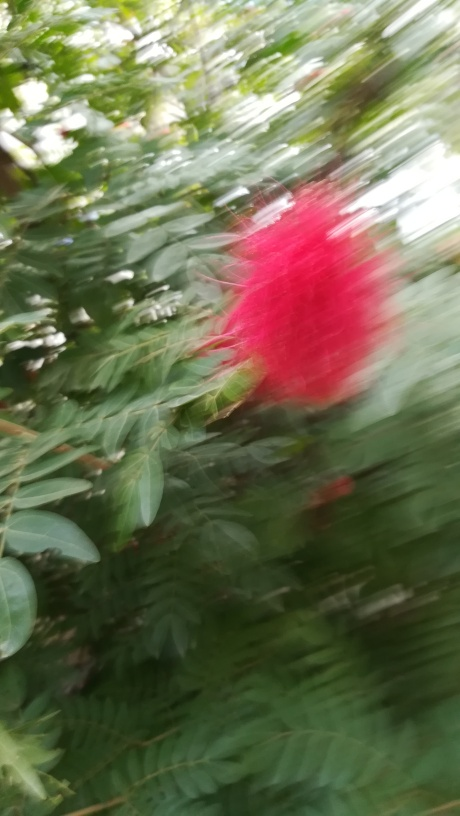How could one improve a photo of this subject under similar conditions? To improve a photo under such conditions, one could use a faster shutter speed to reduce motion blur, ensure proper focus, possibly by using manual focus settings, and use a tripod or stabilize the camera to keep it steady. Additionally, waiting for a moment when the wind has calmed could help in capturing a sharper image. 